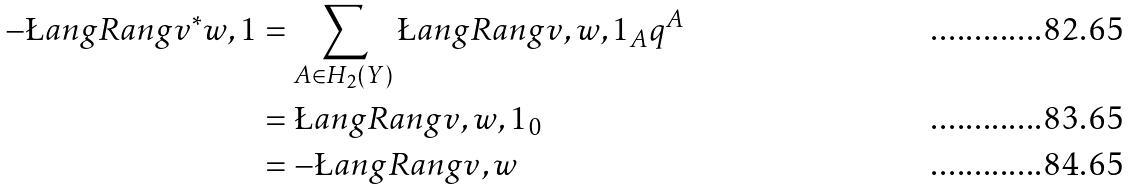<formula> <loc_0><loc_0><loc_500><loc_500>- \L a n g R a n g { v ^ { * } w , 1 } & = \sum _ { A \in H _ { 2 } ( Y ) } \L a n g R a n g { v , w , 1 } _ { A } q ^ { A } \\ & = \L a n g R a n g { v , w , 1 } _ { 0 } \\ & = - \L a n g R a n g { v , w }</formula> 